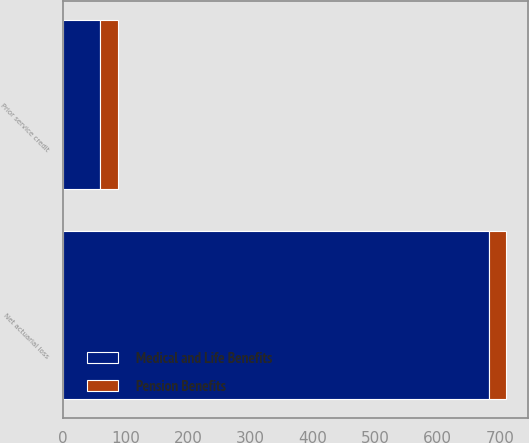Convert chart. <chart><loc_0><loc_0><loc_500><loc_500><stacked_bar_chart><ecel><fcel>Net actuarial loss<fcel>Prior service credit<nl><fcel>Medical and Life Benefits<fcel>682<fcel>60<nl><fcel>Pension Benefits<fcel>27<fcel>28<nl></chart> 